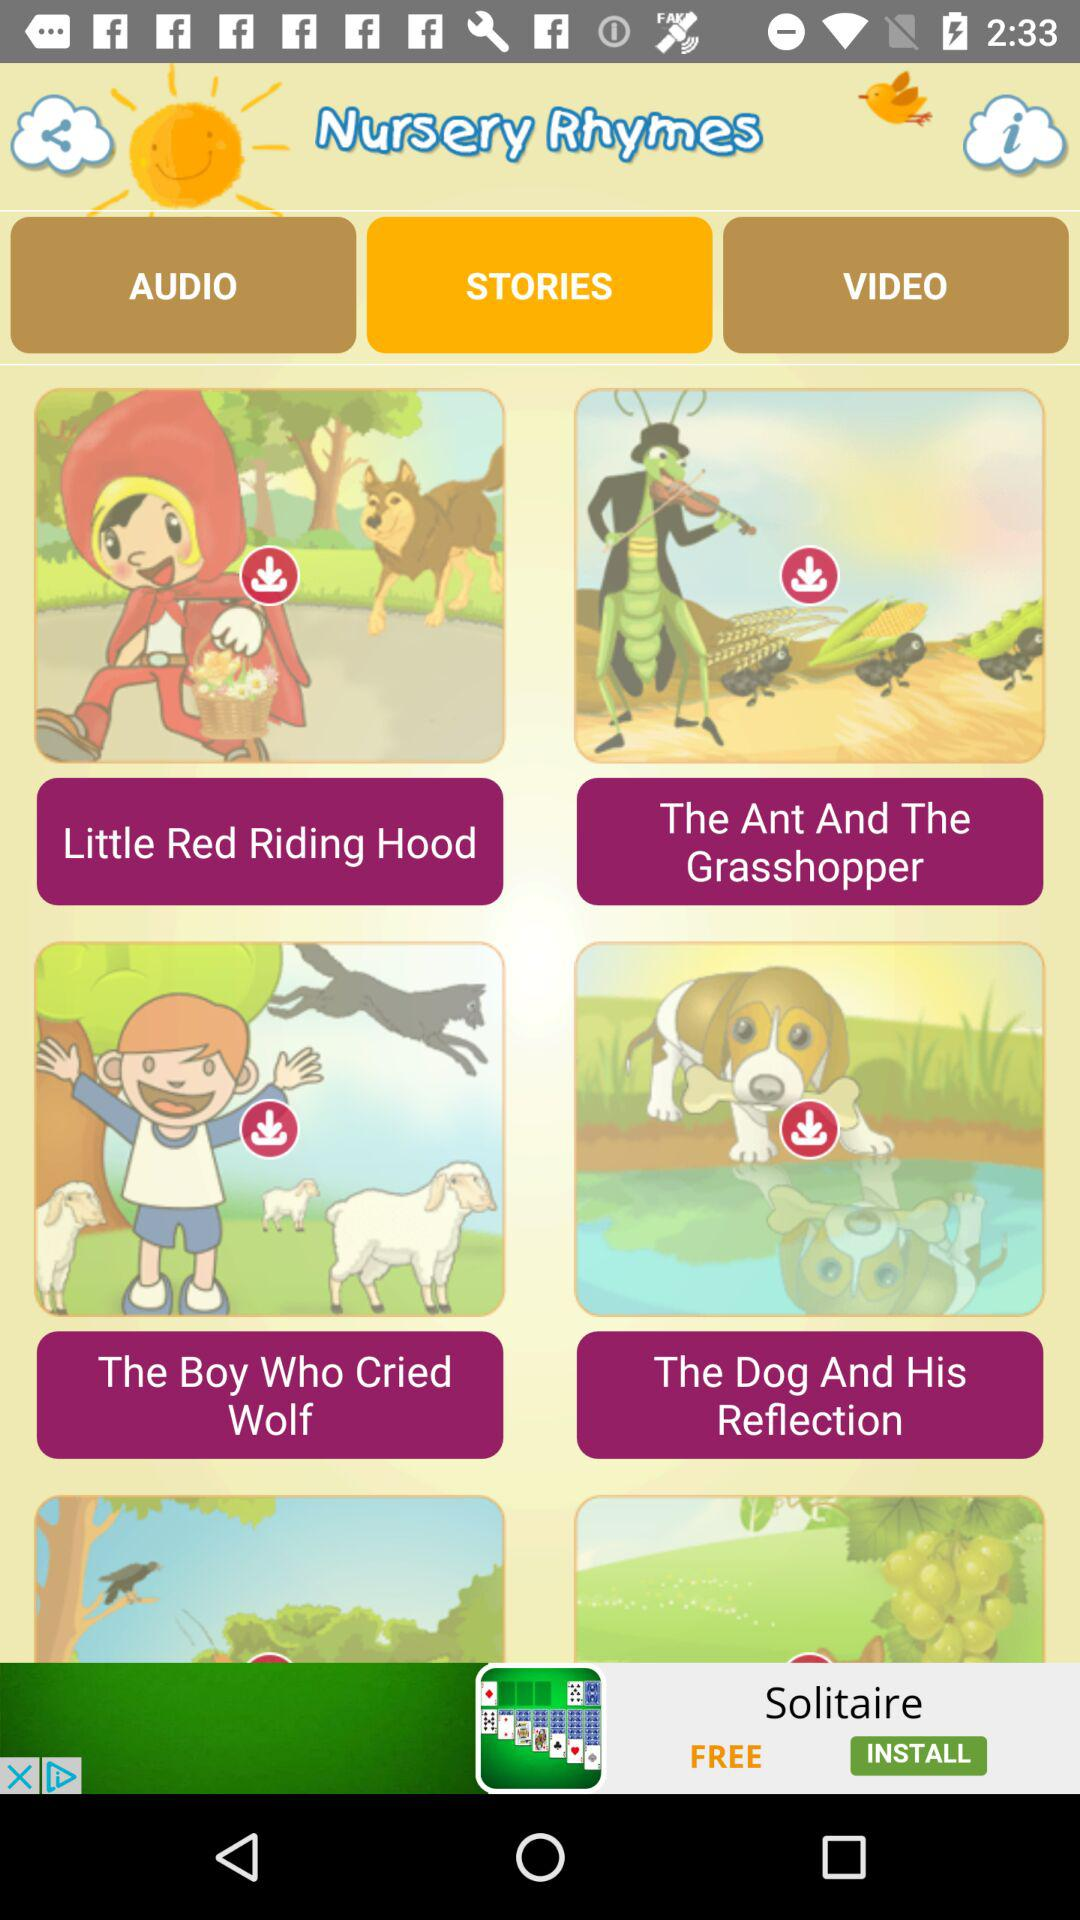Which option is selected in "Nursery Rhymes"? The selected option is "STORIES". 